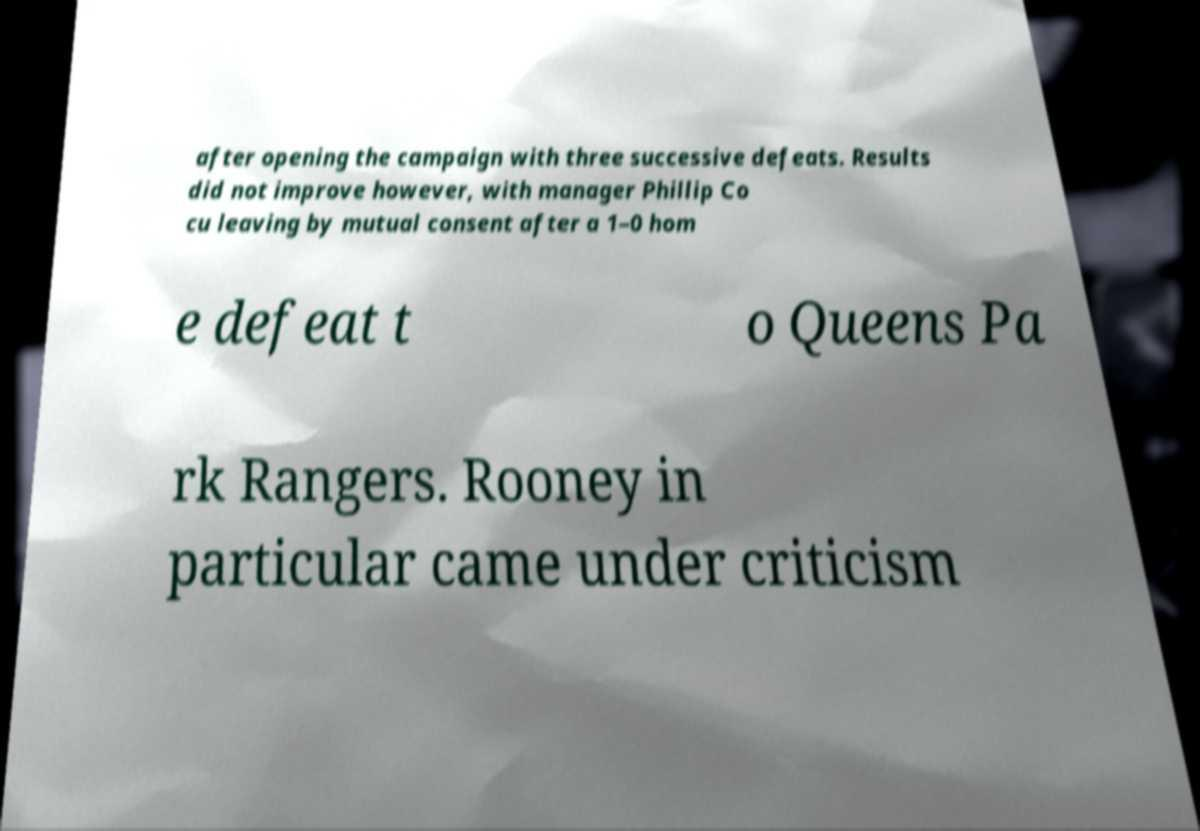I need the written content from this picture converted into text. Can you do that? after opening the campaign with three successive defeats. Results did not improve however, with manager Phillip Co cu leaving by mutual consent after a 1–0 hom e defeat t o Queens Pa rk Rangers. Rooney in particular came under criticism 